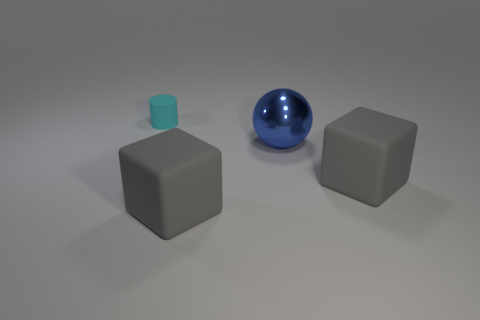How many large shiny balls are there?
Your response must be concise. 1. Does the big gray object to the right of the blue metallic thing have the same shape as the large gray thing that is to the left of the blue sphere?
Make the answer very short. Yes. There is a rubber thing that is behind the large matte object that is behind the big rubber cube that is left of the blue shiny sphere; what color is it?
Make the answer very short. Cyan. There is a cube to the left of the shiny ball; what color is it?
Offer a very short reply. Gray. What number of small cylinders are right of the metal object?
Provide a short and direct response. 0. How many objects are matte objects that are in front of the small matte object or small matte objects?
Make the answer very short. 3. Are there more tiny matte things that are on the left side of the blue metallic thing than shiny spheres left of the tiny cylinder?
Offer a terse response. Yes. Is the size of the sphere the same as the cylinder behind the large blue sphere?
Offer a very short reply. No. What number of blocks are either matte things or big things?
Provide a short and direct response. 2. Does the matte block to the right of the large blue object have the same size as the cyan rubber cylinder that is left of the blue ball?
Make the answer very short. No. 